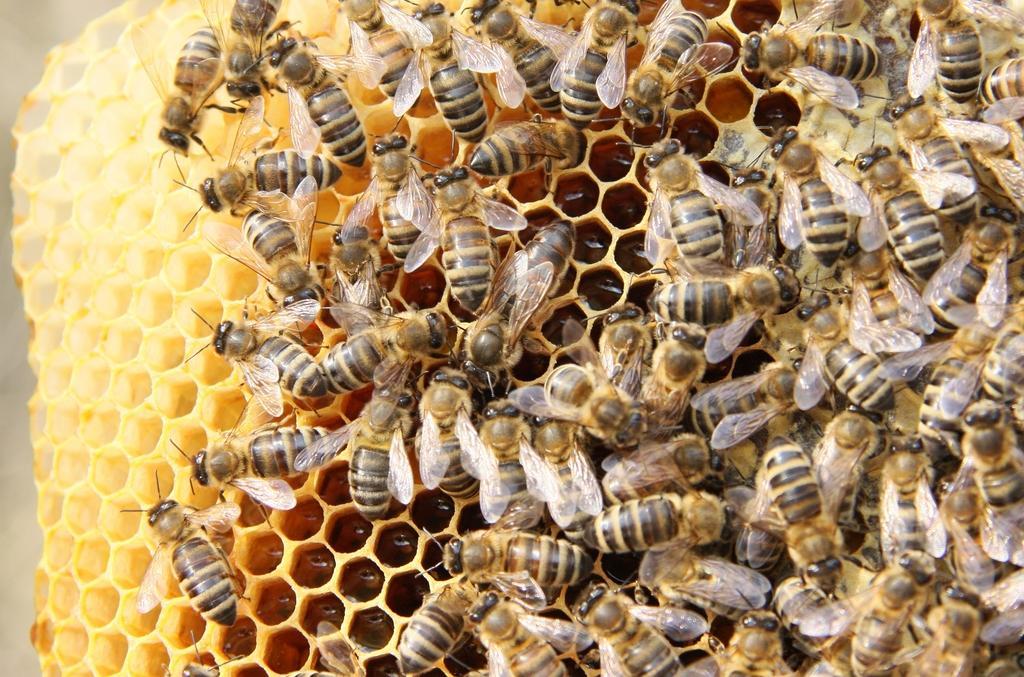Please provide a concise description of this image. In this image there are so many honey bees on the honeycomb. 